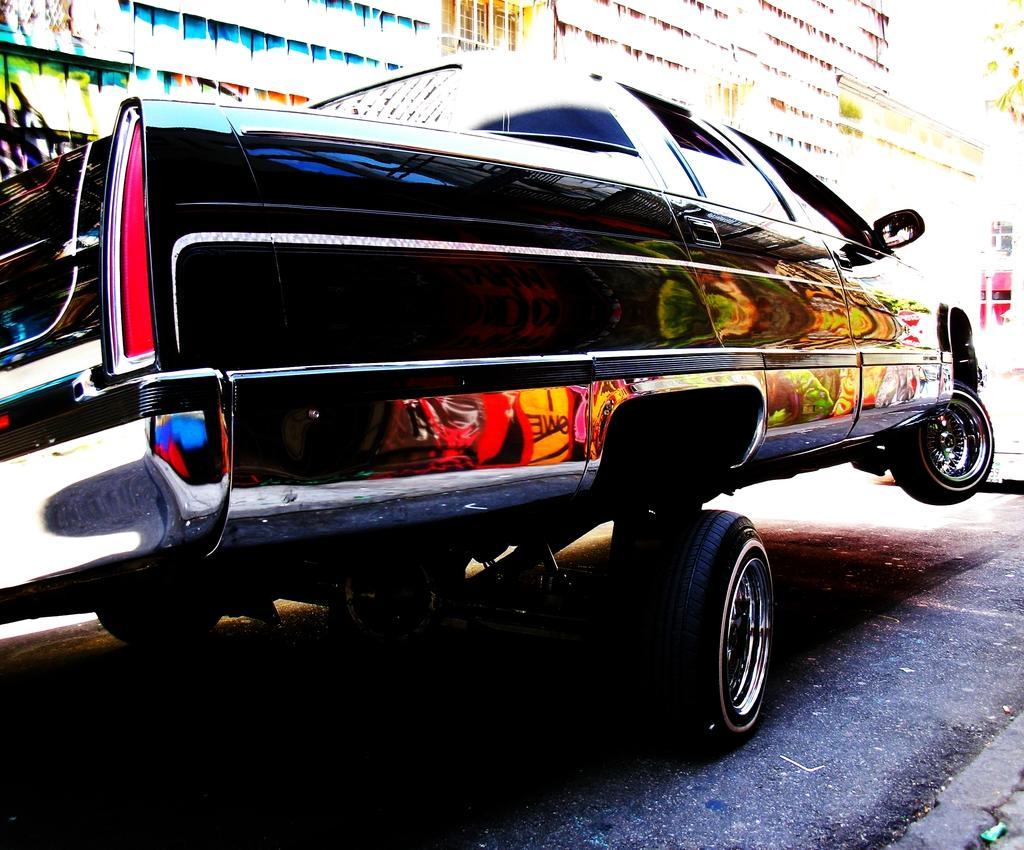Can you describe this image briefly? In the image in the center, we can see one vehicle on the road. In the background we can see buildings, trees etc. 